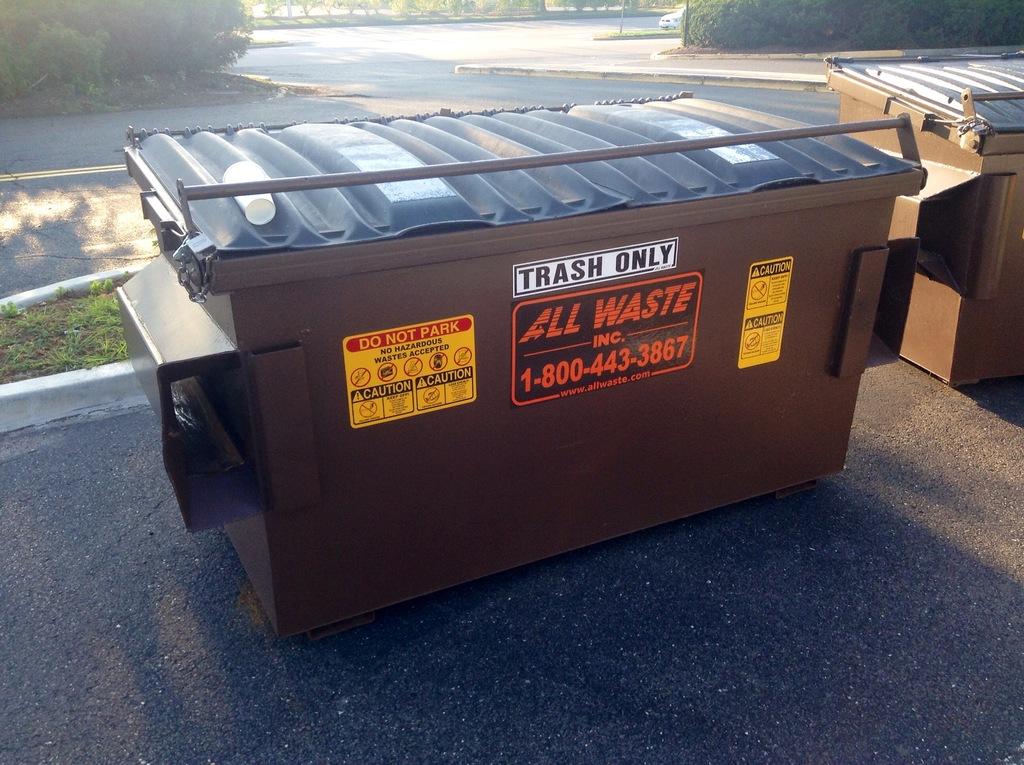What is the only thing you can put in the container?
Provide a succinct answer. Trash. What is the name of the company that owns the container?
Offer a terse response. All waste. 